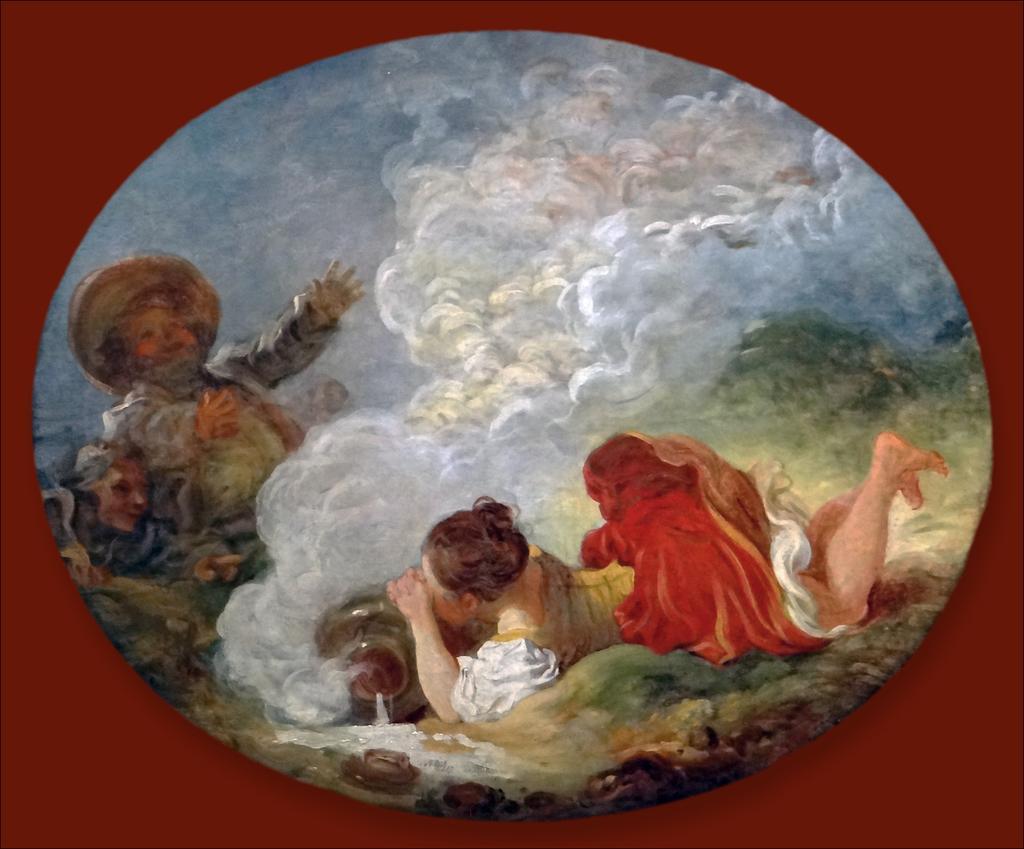Can you describe this image briefly? In this image I can see a painting of three people were two of them are women and one is a man. I can also see a woman is holding a container. 